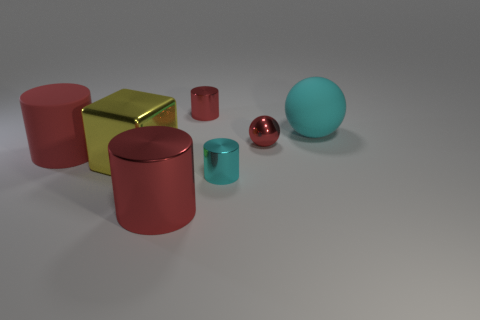How many red cylinders must be subtracted to get 1 red cylinders? 2 Subtract all blue balls. How many red cylinders are left? 3 Add 3 large yellow metallic blocks. How many objects exist? 10 Subtract all cylinders. How many objects are left? 3 Subtract all brown rubber objects. Subtract all cylinders. How many objects are left? 3 Add 5 shiny things. How many shiny things are left? 10 Add 3 large red rubber things. How many large red rubber things exist? 4 Subtract 1 red balls. How many objects are left? 6 